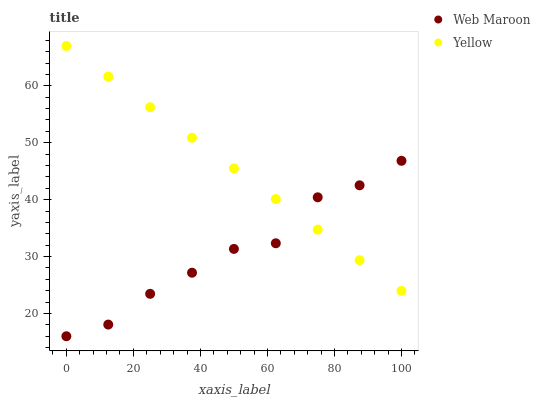Does Web Maroon have the minimum area under the curve?
Answer yes or no. Yes. Does Yellow have the maximum area under the curve?
Answer yes or no. Yes. Does Yellow have the minimum area under the curve?
Answer yes or no. No. Is Yellow the smoothest?
Answer yes or no. Yes. Is Web Maroon the roughest?
Answer yes or no. Yes. Is Yellow the roughest?
Answer yes or no. No. Does Web Maroon have the lowest value?
Answer yes or no. Yes. Does Yellow have the lowest value?
Answer yes or no. No. Does Yellow have the highest value?
Answer yes or no. Yes. Does Yellow intersect Web Maroon?
Answer yes or no. Yes. Is Yellow less than Web Maroon?
Answer yes or no. No. Is Yellow greater than Web Maroon?
Answer yes or no. No. 